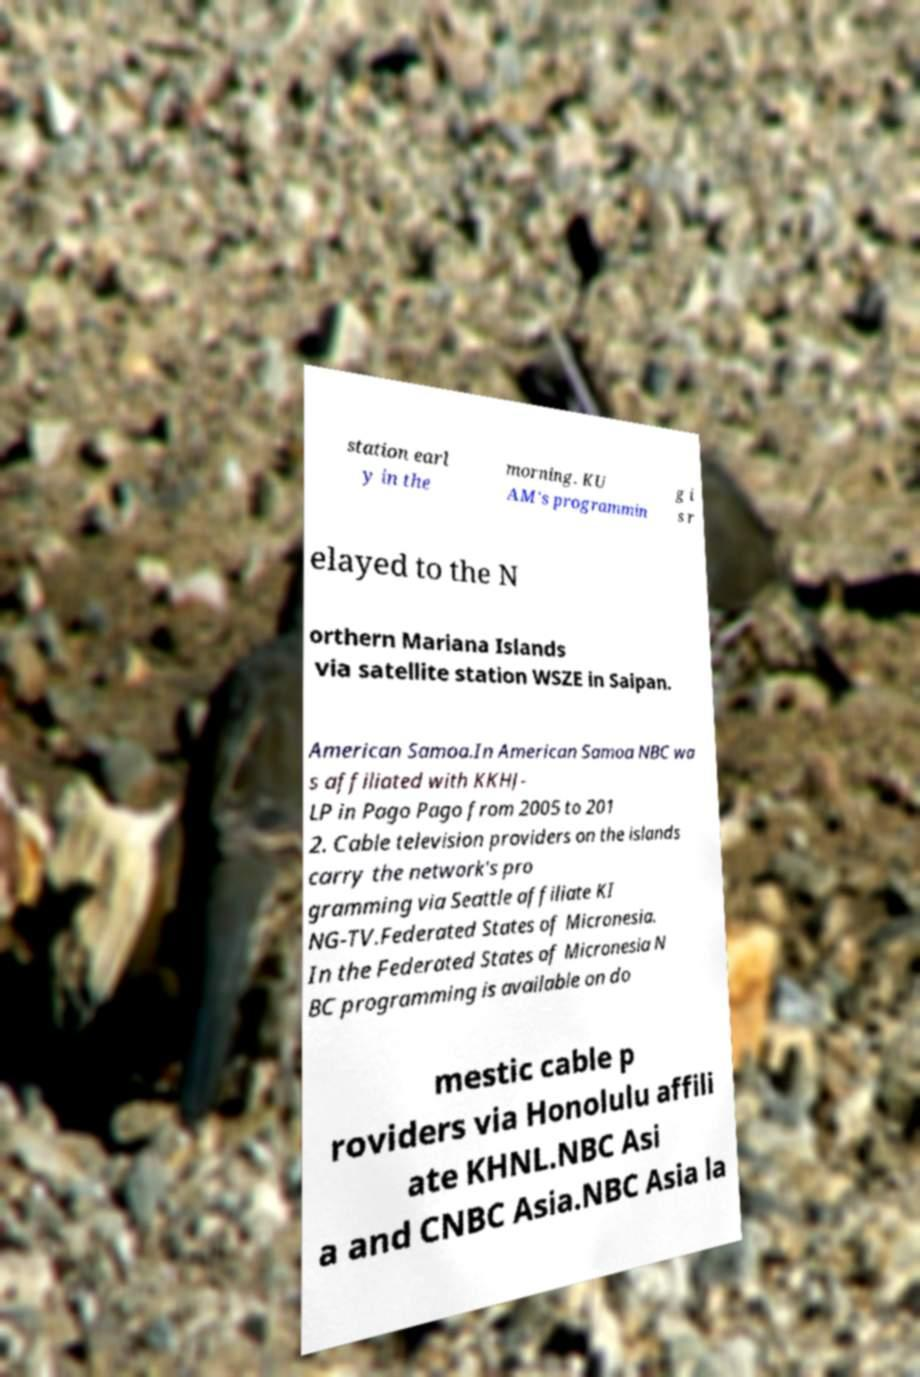Could you assist in decoding the text presented in this image and type it out clearly? station earl y in the morning. KU AM's programmin g i s r elayed to the N orthern Mariana Islands via satellite station WSZE in Saipan. American Samoa.In American Samoa NBC wa s affiliated with KKHJ- LP in Pago Pago from 2005 to 201 2. Cable television providers on the islands carry the network's pro gramming via Seattle affiliate KI NG-TV.Federated States of Micronesia. In the Federated States of Micronesia N BC programming is available on do mestic cable p roviders via Honolulu affili ate KHNL.NBC Asi a and CNBC Asia.NBC Asia la 